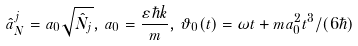<formula> <loc_0><loc_0><loc_500><loc_500>\hat { a } _ { N } ^ { j } = a _ { 0 } \sqrt { \hat { N } _ { j } } , \, a _ { 0 } = \frac { \varepsilon \hbar { k } } { m } , \, \vartheta _ { 0 } ( t ) = \omega t + m a _ { 0 } ^ { 2 } t ^ { 3 } / ( 6 \hbar { ) }</formula> 